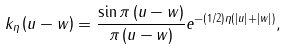<formula> <loc_0><loc_0><loc_500><loc_500>k _ { \eta } \left ( u - w \right ) = \frac { \sin \pi \left ( u - w \right ) } { \pi \left ( u - w \right ) } e ^ { - \left ( 1 / 2 \right ) \eta \left ( \left | u \right | + \left | w \right | \right ) } ,</formula> 